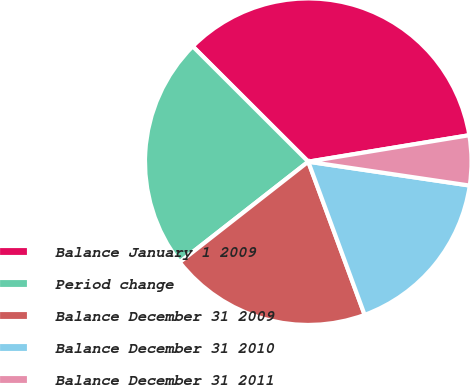Convert chart to OTSL. <chart><loc_0><loc_0><loc_500><loc_500><pie_chart><fcel>Balance January 1 2009<fcel>Period change<fcel>Balance December 31 2009<fcel>Balance December 31 2010<fcel>Balance December 31 2011<nl><fcel>34.92%<fcel>23.05%<fcel>20.05%<fcel>17.05%<fcel>4.93%<nl></chart> 